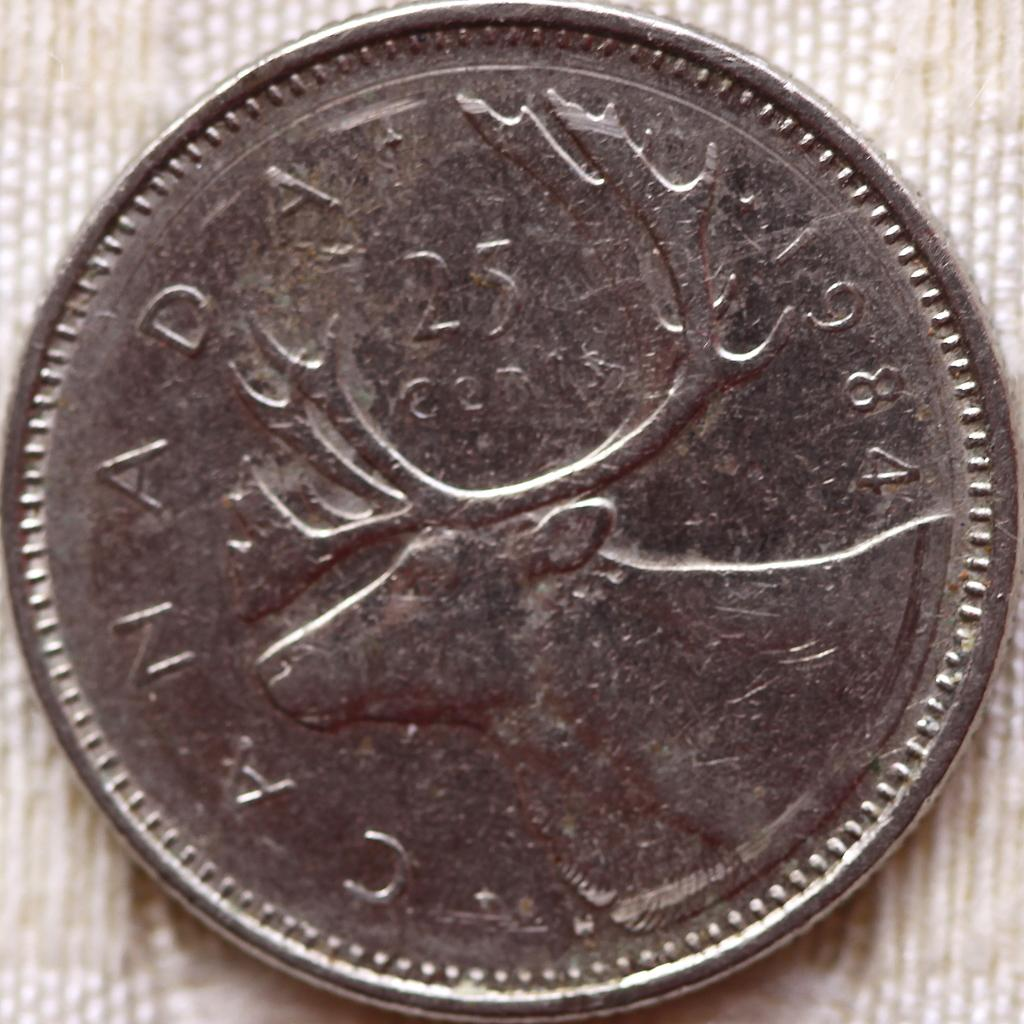Provide a one-sentence caption for the provided image. a  silver canadian quarter with a deer on it. 